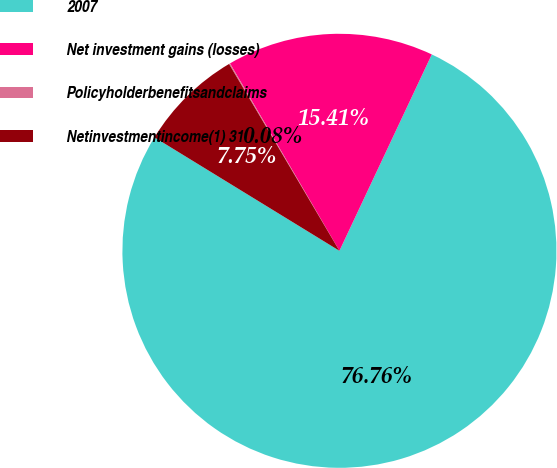Convert chart. <chart><loc_0><loc_0><loc_500><loc_500><pie_chart><fcel>2007<fcel>Net investment gains (losses)<fcel>Policyholderbenefitsandclaims<fcel>Netinvestmentincome(1) 31<nl><fcel>76.76%<fcel>15.41%<fcel>0.08%<fcel>7.75%<nl></chart> 